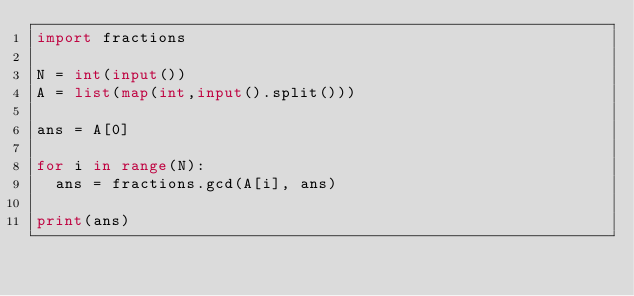<code> <loc_0><loc_0><loc_500><loc_500><_Python_>import fractions

N = int(input())
A = list(map(int,input().split()))

ans = A[0]

for i in range(N):
  ans = fractions.gcd(A[i], ans)
  
print(ans)</code> 